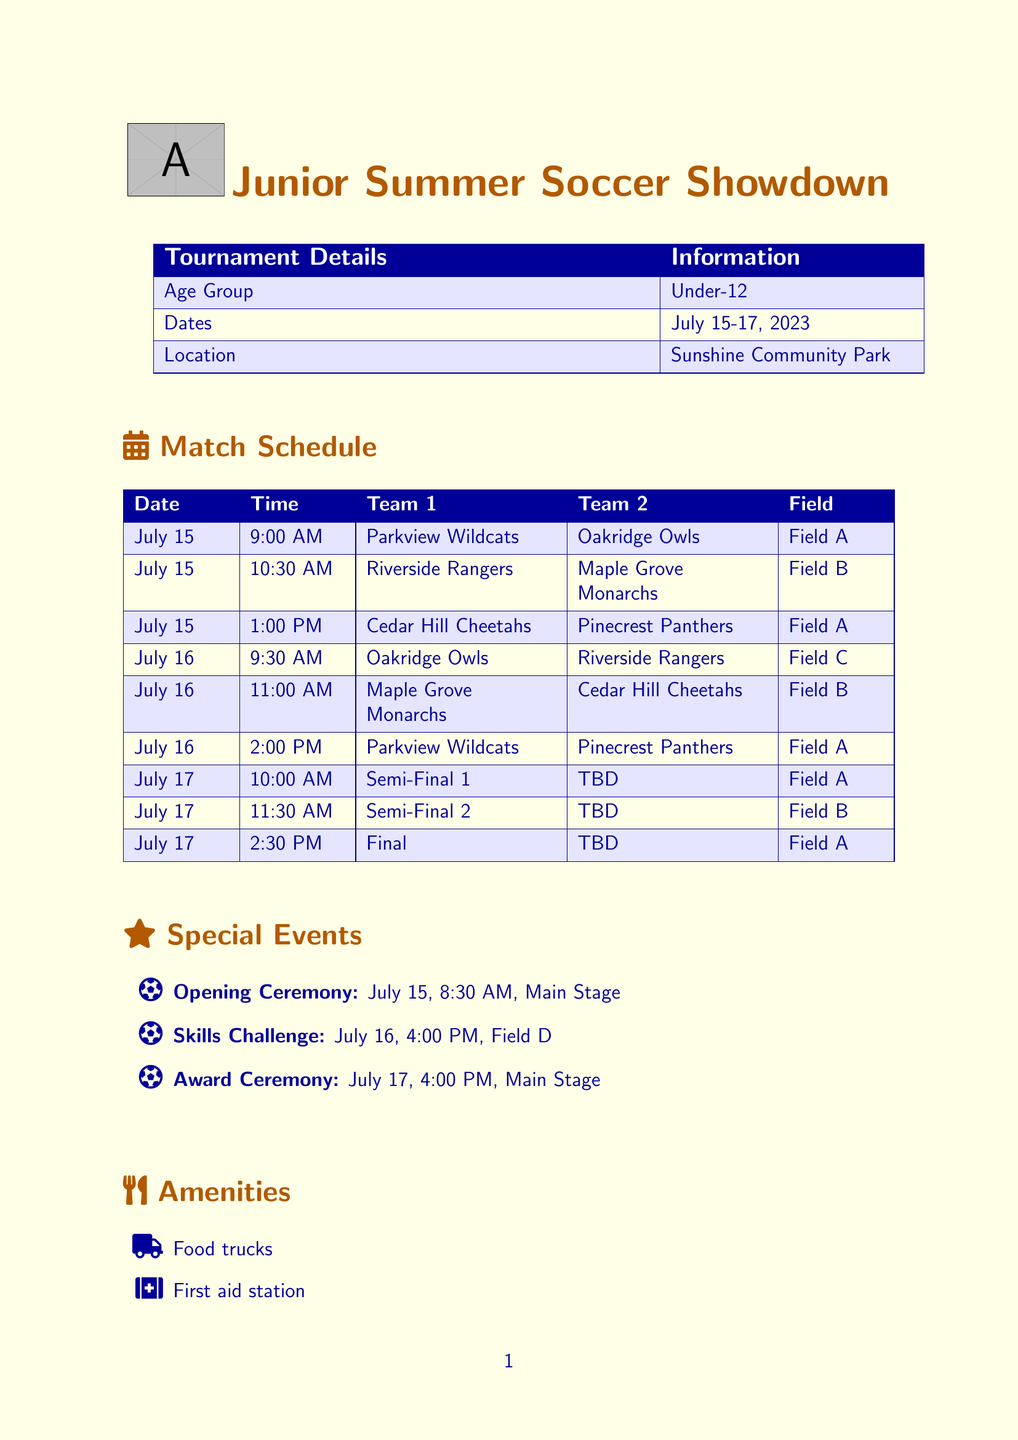What are the tournament dates? The tournament dates are clearly mentioned in the schedule as July 15-17, 2023.
Answer: July 15-17, 2023 Which field is used for the Semi-Final 1 match? The field assignment for Semi-Final 1 is noted in the match schedule.
Answer: Field A What teams play against each other at 10:30 AM on July 15? The schedule lists the teams and their match times, indicating the teams for the specified time.
Answer: Riverside Rangers and Maple Grove Monarchs What special event occurs on July 16 at 4:00 PM? The list of special events identifies the activity scheduled for that date and time.
Answer: Skills Challenge How many teams are playing on July 17? The match schedule includes Semi-Final and Final matches, indicating participation.
Answer: 3 teams What is stated as an important note regarding cleats? Important notes regarding participation rules are outlined in the relevant section of the document.
Answer: No cleats allowed on artificial turf fields What is the location of the Opening Ceremony? The special event details specify the location for the Opening Ceremony.
Answer: Main Stage What team plays against the Parkview Wildcats on July 16? The match schedule shows the matchups for that date and identifies the opponent.
Answer: Pinecrest Panthers 